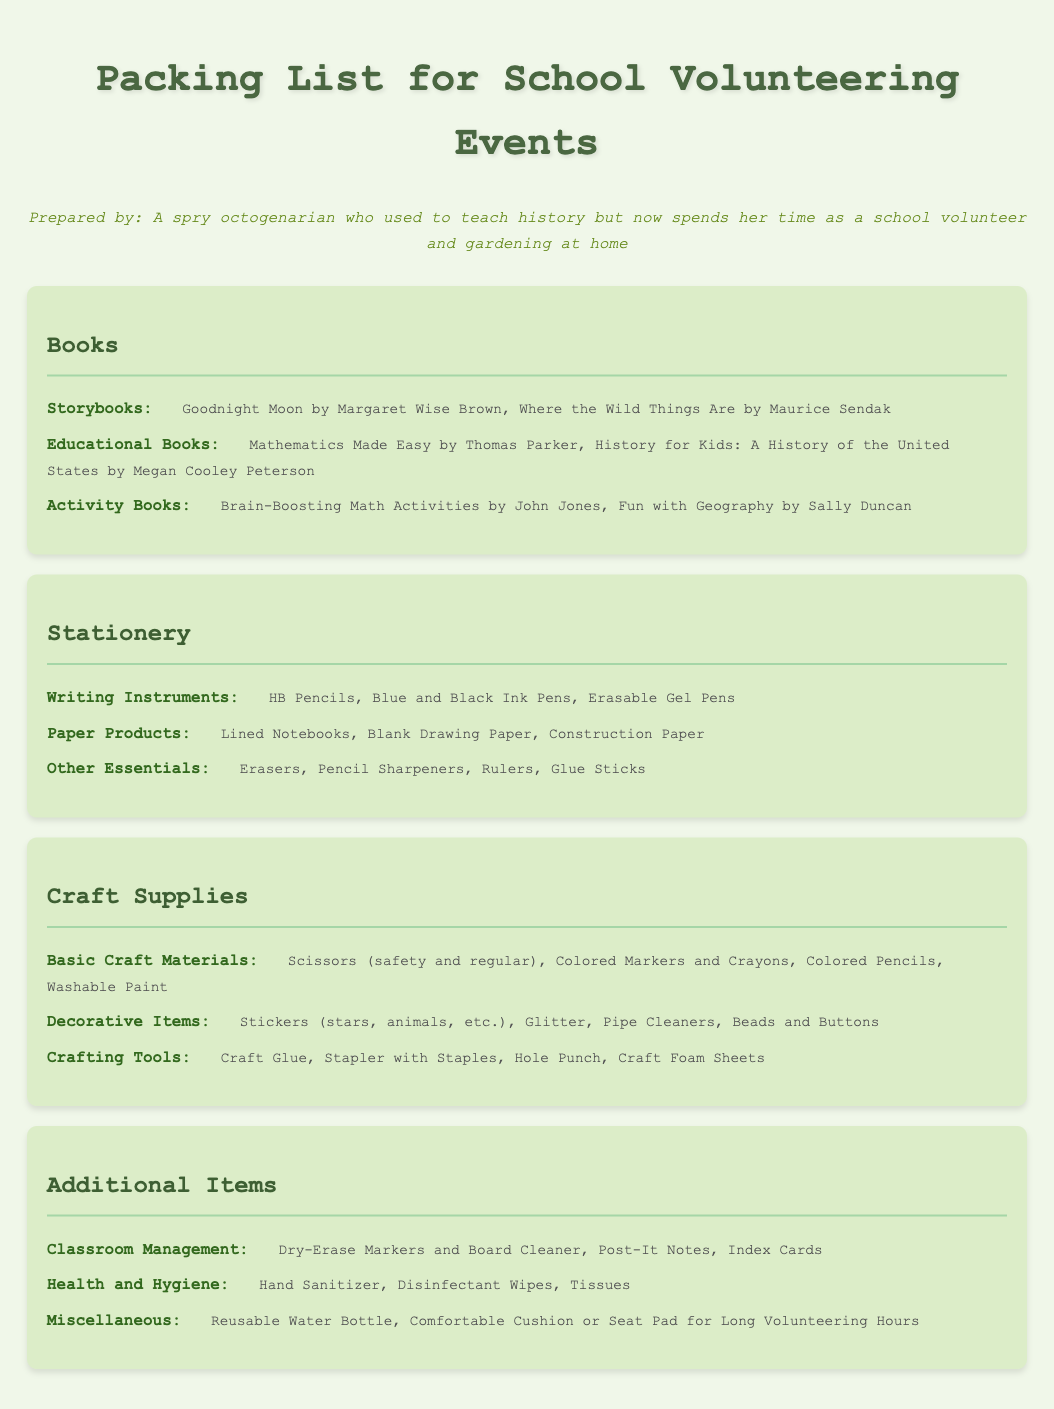What are the three categories listed in the packing list? The packing list is organized into categories: Books, Stationery, Craft Supplies, and Additional Items.
Answer: Books, Stationery, Craft Supplies, Additional Items What type of book is "Goodnight Moon"? "Goodnight Moon" is categorized as a Storybook in the list.
Answer: Storybook What type of writing instruments are included in the stationery section? The stationery section includes various writing instruments like HB Pencils, Blue and Black Ink Pens, and Erasable Gel Pens.
Answer: HB Pencils, Blue and Black Ink Pens, Erasable Gel Pens What essential crafting tool is listed along with scissors? Scissors are mentioned alongside Colored Markers and Crayons as basic craft materials.
Answer: Colored Markers and Crayons Which health-related item is suggested to bring? The packing list suggests bringing Hand Sanitizer under the Health and Hygiene category.
Answer: Hand Sanitizer How many types of decorative items are mentioned in the craft supplies? The document mentions four types of decorative items: Stickers, Glitter, Pipe Cleaners, and Beads/Buttons.
Answer: Four What is an activity book mentioned in the document? "Brain-Boosting Math Activities" is an example of an activity book listed.
Answer: Brain-Boosting Math Activities What item is suggested for classroom management? The packing list includes Dry-Erase Markers and Board Cleaner for classroom management.
Answer: Dry-Erase Markers and Board Cleaner What is one of the additional items for comfort during volunteering? A Comfortable Cushion or Seat Pad is suggested as an additional item for comfort.
Answer: Comfortable Cushion or Seat Pad 